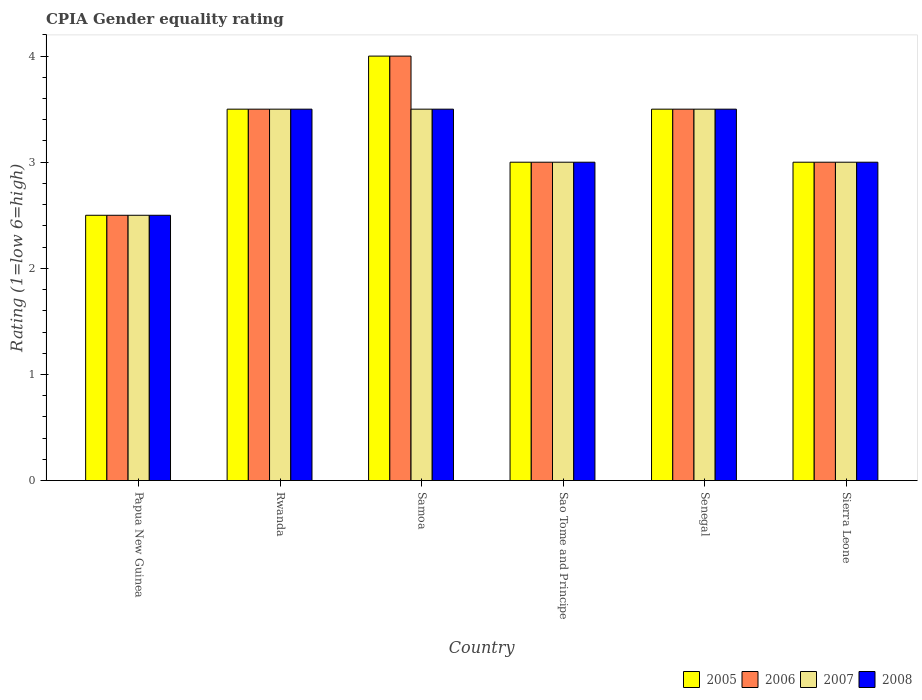How many different coloured bars are there?
Your response must be concise. 4. How many groups of bars are there?
Provide a short and direct response. 6. Are the number of bars per tick equal to the number of legend labels?
Offer a very short reply. Yes. Are the number of bars on each tick of the X-axis equal?
Offer a very short reply. Yes. How many bars are there on the 6th tick from the left?
Ensure brevity in your answer.  4. How many bars are there on the 1st tick from the right?
Your response must be concise. 4. What is the label of the 6th group of bars from the left?
Your response must be concise. Sierra Leone. In how many cases, is the number of bars for a given country not equal to the number of legend labels?
Your answer should be very brief. 0. In which country was the CPIA rating in 2007 maximum?
Ensure brevity in your answer.  Rwanda. In which country was the CPIA rating in 2006 minimum?
Keep it short and to the point. Papua New Guinea. What is the total CPIA rating in 2005 in the graph?
Offer a very short reply. 19.5. What is the difference between the CPIA rating in 2007 in Rwanda and that in Senegal?
Make the answer very short. 0. What is the difference between the CPIA rating in 2005 in Papua New Guinea and the CPIA rating in 2008 in Samoa?
Your answer should be very brief. -1. What is the average CPIA rating in 2005 per country?
Keep it short and to the point. 3.25. What is the ratio of the CPIA rating in 2008 in Senegal to that in Sierra Leone?
Your answer should be very brief. 1.17. What is the difference between the highest and the second highest CPIA rating in 2005?
Your answer should be very brief. -0.5. In how many countries, is the CPIA rating in 2007 greater than the average CPIA rating in 2007 taken over all countries?
Provide a short and direct response. 3. Is it the case that in every country, the sum of the CPIA rating in 2007 and CPIA rating in 2008 is greater than the sum of CPIA rating in 2006 and CPIA rating in 2005?
Make the answer very short. No. Is it the case that in every country, the sum of the CPIA rating in 2007 and CPIA rating in 2006 is greater than the CPIA rating in 2005?
Make the answer very short. Yes. How many bars are there?
Your response must be concise. 24. What is the difference between two consecutive major ticks on the Y-axis?
Offer a very short reply. 1. Are the values on the major ticks of Y-axis written in scientific E-notation?
Give a very brief answer. No. Does the graph contain any zero values?
Give a very brief answer. No. Does the graph contain grids?
Make the answer very short. No. Where does the legend appear in the graph?
Your answer should be very brief. Bottom right. What is the title of the graph?
Offer a terse response. CPIA Gender equality rating. What is the Rating (1=low 6=high) of 2006 in Papua New Guinea?
Offer a terse response. 2.5. What is the Rating (1=low 6=high) of 2008 in Papua New Guinea?
Offer a very short reply. 2.5. What is the Rating (1=low 6=high) of 2005 in Rwanda?
Make the answer very short. 3.5. What is the Rating (1=low 6=high) in 2007 in Rwanda?
Offer a terse response. 3.5. What is the Rating (1=low 6=high) in 2008 in Samoa?
Ensure brevity in your answer.  3.5. What is the Rating (1=low 6=high) of 2005 in Sao Tome and Principe?
Ensure brevity in your answer.  3. What is the Rating (1=low 6=high) of 2006 in Sao Tome and Principe?
Provide a short and direct response. 3. What is the Rating (1=low 6=high) of 2007 in Sao Tome and Principe?
Offer a terse response. 3. What is the Rating (1=low 6=high) in 2008 in Sao Tome and Principe?
Provide a short and direct response. 3. What is the Rating (1=low 6=high) of 2005 in Sierra Leone?
Provide a succinct answer. 3. What is the Rating (1=low 6=high) of 2006 in Sierra Leone?
Your answer should be very brief. 3. What is the Rating (1=low 6=high) in 2007 in Sierra Leone?
Your response must be concise. 3. What is the Rating (1=low 6=high) in 2008 in Sierra Leone?
Ensure brevity in your answer.  3. Across all countries, what is the maximum Rating (1=low 6=high) in 2006?
Provide a short and direct response. 4. Across all countries, what is the minimum Rating (1=low 6=high) of 2006?
Ensure brevity in your answer.  2.5. Across all countries, what is the minimum Rating (1=low 6=high) of 2008?
Make the answer very short. 2.5. What is the total Rating (1=low 6=high) of 2005 in the graph?
Give a very brief answer. 19.5. What is the total Rating (1=low 6=high) in 2006 in the graph?
Offer a very short reply. 19.5. What is the total Rating (1=low 6=high) in 2008 in the graph?
Keep it short and to the point. 19. What is the difference between the Rating (1=low 6=high) of 2006 in Papua New Guinea and that in Rwanda?
Give a very brief answer. -1. What is the difference between the Rating (1=low 6=high) of 2008 in Papua New Guinea and that in Rwanda?
Keep it short and to the point. -1. What is the difference between the Rating (1=low 6=high) in 2006 in Papua New Guinea and that in Samoa?
Provide a succinct answer. -1.5. What is the difference between the Rating (1=low 6=high) of 2007 in Papua New Guinea and that in Samoa?
Your answer should be very brief. -1. What is the difference between the Rating (1=low 6=high) of 2005 in Papua New Guinea and that in Senegal?
Make the answer very short. -1. What is the difference between the Rating (1=low 6=high) of 2006 in Papua New Guinea and that in Senegal?
Give a very brief answer. -1. What is the difference between the Rating (1=low 6=high) of 2007 in Papua New Guinea and that in Senegal?
Provide a succinct answer. -1. What is the difference between the Rating (1=low 6=high) of 2008 in Papua New Guinea and that in Senegal?
Ensure brevity in your answer.  -1. What is the difference between the Rating (1=low 6=high) of 2005 in Papua New Guinea and that in Sierra Leone?
Provide a succinct answer. -0.5. What is the difference between the Rating (1=low 6=high) of 2006 in Papua New Guinea and that in Sierra Leone?
Your answer should be compact. -0.5. What is the difference between the Rating (1=low 6=high) of 2008 in Papua New Guinea and that in Sierra Leone?
Offer a terse response. -0.5. What is the difference between the Rating (1=low 6=high) in 2006 in Rwanda and that in Samoa?
Provide a short and direct response. -0.5. What is the difference between the Rating (1=low 6=high) in 2007 in Rwanda and that in Samoa?
Offer a terse response. 0. What is the difference between the Rating (1=low 6=high) of 2005 in Rwanda and that in Sao Tome and Principe?
Offer a very short reply. 0.5. What is the difference between the Rating (1=low 6=high) in 2007 in Rwanda and that in Sao Tome and Principe?
Ensure brevity in your answer.  0.5. What is the difference between the Rating (1=low 6=high) in 2008 in Rwanda and that in Sao Tome and Principe?
Ensure brevity in your answer.  0.5. What is the difference between the Rating (1=low 6=high) in 2006 in Rwanda and that in Senegal?
Your response must be concise. 0. What is the difference between the Rating (1=low 6=high) in 2007 in Rwanda and that in Senegal?
Your answer should be very brief. 0. What is the difference between the Rating (1=low 6=high) of 2008 in Rwanda and that in Senegal?
Your response must be concise. 0. What is the difference between the Rating (1=low 6=high) in 2005 in Rwanda and that in Sierra Leone?
Your answer should be very brief. 0.5. What is the difference between the Rating (1=low 6=high) in 2007 in Rwanda and that in Sierra Leone?
Provide a short and direct response. 0.5. What is the difference between the Rating (1=low 6=high) of 2008 in Rwanda and that in Sierra Leone?
Your answer should be compact. 0.5. What is the difference between the Rating (1=low 6=high) in 2005 in Samoa and that in Sao Tome and Principe?
Offer a terse response. 1. What is the difference between the Rating (1=low 6=high) in 2007 in Samoa and that in Sao Tome and Principe?
Your answer should be compact. 0.5. What is the difference between the Rating (1=low 6=high) of 2008 in Samoa and that in Sao Tome and Principe?
Make the answer very short. 0.5. What is the difference between the Rating (1=low 6=high) of 2005 in Samoa and that in Senegal?
Your answer should be compact. 0.5. What is the difference between the Rating (1=low 6=high) in 2006 in Samoa and that in Sierra Leone?
Your answer should be very brief. 1. What is the difference between the Rating (1=low 6=high) in 2007 in Samoa and that in Sierra Leone?
Provide a succinct answer. 0.5. What is the difference between the Rating (1=low 6=high) of 2008 in Samoa and that in Sierra Leone?
Give a very brief answer. 0.5. What is the difference between the Rating (1=low 6=high) in 2006 in Sao Tome and Principe and that in Senegal?
Your answer should be very brief. -0.5. What is the difference between the Rating (1=low 6=high) of 2008 in Sao Tome and Principe and that in Senegal?
Provide a short and direct response. -0.5. What is the difference between the Rating (1=low 6=high) in 2005 in Sao Tome and Principe and that in Sierra Leone?
Make the answer very short. 0. What is the difference between the Rating (1=low 6=high) of 2007 in Sao Tome and Principe and that in Sierra Leone?
Offer a very short reply. 0. What is the difference between the Rating (1=low 6=high) of 2008 in Sao Tome and Principe and that in Sierra Leone?
Provide a succinct answer. 0. What is the difference between the Rating (1=low 6=high) in 2007 in Senegal and that in Sierra Leone?
Your response must be concise. 0.5. What is the difference between the Rating (1=low 6=high) in 2008 in Senegal and that in Sierra Leone?
Provide a short and direct response. 0.5. What is the difference between the Rating (1=low 6=high) of 2006 in Papua New Guinea and the Rating (1=low 6=high) of 2007 in Rwanda?
Offer a terse response. -1. What is the difference between the Rating (1=low 6=high) of 2007 in Papua New Guinea and the Rating (1=low 6=high) of 2008 in Rwanda?
Your answer should be compact. -1. What is the difference between the Rating (1=low 6=high) in 2005 in Papua New Guinea and the Rating (1=low 6=high) in 2008 in Samoa?
Keep it short and to the point. -1. What is the difference between the Rating (1=low 6=high) in 2006 in Papua New Guinea and the Rating (1=low 6=high) in 2007 in Samoa?
Your answer should be compact. -1. What is the difference between the Rating (1=low 6=high) in 2007 in Papua New Guinea and the Rating (1=low 6=high) in 2008 in Samoa?
Your answer should be compact. -1. What is the difference between the Rating (1=low 6=high) in 2006 in Papua New Guinea and the Rating (1=low 6=high) in 2007 in Sao Tome and Principe?
Ensure brevity in your answer.  -0.5. What is the difference between the Rating (1=low 6=high) in 2007 in Papua New Guinea and the Rating (1=low 6=high) in 2008 in Sao Tome and Principe?
Keep it short and to the point. -0.5. What is the difference between the Rating (1=low 6=high) in 2005 in Papua New Guinea and the Rating (1=low 6=high) in 2006 in Senegal?
Your response must be concise. -1. What is the difference between the Rating (1=low 6=high) in 2005 in Papua New Guinea and the Rating (1=low 6=high) in 2007 in Senegal?
Make the answer very short. -1. What is the difference between the Rating (1=low 6=high) of 2007 in Papua New Guinea and the Rating (1=low 6=high) of 2008 in Senegal?
Ensure brevity in your answer.  -1. What is the difference between the Rating (1=low 6=high) in 2005 in Papua New Guinea and the Rating (1=low 6=high) in 2006 in Sierra Leone?
Your response must be concise. -0.5. What is the difference between the Rating (1=low 6=high) of 2006 in Papua New Guinea and the Rating (1=low 6=high) of 2008 in Sierra Leone?
Offer a terse response. -0.5. What is the difference between the Rating (1=low 6=high) in 2007 in Papua New Guinea and the Rating (1=low 6=high) in 2008 in Sierra Leone?
Ensure brevity in your answer.  -0.5. What is the difference between the Rating (1=low 6=high) of 2005 in Rwanda and the Rating (1=low 6=high) of 2006 in Samoa?
Provide a short and direct response. -0.5. What is the difference between the Rating (1=low 6=high) in 2005 in Rwanda and the Rating (1=low 6=high) in 2007 in Samoa?
Offer a terse response. 0. What is the difference between the Rating (1=low 6=high) in 2005 in Rwanda and the Rating (1=low 6=high) in 2008 in Samoa?
Your answer should be very brief. 0. What is the difference between the Rating (1=low 6=high) in 2006 in Rwanda and the Rating (1=low 6=high) in 2007 in Samoa?
Offer a terse response. 0. What is the difference between the Rating (1=low 6=high) in 2006 in Rwanda and the Rating (1=low 6=high) in 2008 in Sao Tome and Principe?
Your response must be concise. 0.5. What is the difference between the Rating (1=low 6=high) of 2005 in Rwanda and the Rating (1=low 6=high) of 2008 in Senegal?
Keep it short and to the point. 0. What is the difference between the Rating (1=low 6=high) of 2005 in Rwanda and the Rating (1=low 6=high) of 2006 in Sierra Leone?
Offer a terse response. 0.5. What is the difference between the Rating (1=low 6=high) of 2005 in Rwanda and the Rating (1=low 6=high) of 2007 in Sierra Leone?
Keep it short and to the point. 0.5. What is the difference between the Rating (1=low 6=high) of 2005 in Rwanda and the Rating (1=low 6=high) of 2008 in Sierra Leone?
Provide a succinct answer. 0.5. What is the difference between the Rating (1=low 6=high) in 2006 in Rwanda and the Rating (1=low 6=high) in 2007 in Sierra Leone?
Offer a terse response. 0.5. What is the difference between the Rating (1=low 6=high) in 2006 in Rwanda and the Rating (1=low 6=high) in 2008 in Sierra Leone?
Ensure brevity in your answer.  0.5. What is the difference between the Rating (1=low 6=high) of 2007 in Rwanda and the Rating (1=low 6=high) of 2008 in Sierra Leone?
Offer a terse response. 0.5. What is the difference between the Rating (1=low 6=high) in 2005 in Samoa and the Rating (1=low 6=high) in 2006 in Sao Tome and Principe?
Offer a very short reply. 1. What is the difference between the Rating (1=low 6=high) in 2005 in Samoa and the Rating (1=low 6=high) in 2007 in Sao Tome and Principe?
Provide a succinct answer. 1. What is the difference between the Rating (1=low 6=high) of 2006 in Samoa and the Rating (1=low 6=high) of 2007 in Sao Tome and Principe?
Your response must be concise. 1. What is the difference between the Rating (1=low 6=high) of 2005 in Samoa and the Rating (1=low 6=high) of 2008 in Senegal?
Give a very brief answer. 0.5. What is the difference between the Rating (1=low 6=high) in 2006 in Samoa and the Rating (1=low 6=high) in 2007 in Senegal?
Your response must be concise. 0.5. What is the difference between the Rating (1=low 6=high) in 2007 in Samoa and the Rating (1=low 6=high) in 2008 in Senegal?
Give a very brief answer. 0. What is the difference between the Rating (1=low 6=high) of 2005 in Samoa and the Rating (1=low 6=high) of 2006 in Sierra Leone?
Provide a succinct answer. 1. What is the difference between the Rating (1=low 6=high) in 2005 in Samoa and the Rating (1=low 6=high) in 2007 in Sierra Leone?
Offer a terse response. 1. What is the difference between the Rating (1=low 6=high) of 2005 in Samoa and the Rating (1=low 6=high) of 2008 in Sierra Leone?
Provide a short and direct response. 1. What is the difference between the Rating (1=low 6=high) of 2006 in Samoa and the Rating (1=low 6=high) of 2007 in Sierra Leone?
Ensure brevity in your answer.  1. What is the difference between the Rating (1=low 6=high) in 2006 in Samoa and the Rating (1=low 6=high) in 2008 in Sierra Leone?
Your response must be concise. 1. What is the difference between the Rating (1=low 6=high) of 2007 in Samoa and the Rating (1=low 6=high) of 2008 in Sierra Leone?
Make the answer very short. 0.5. What is the difference between the Rating (1=low 6=high) in 2005 in Sao Tome and Principe and the Rating (1=low 6=high) in 2007 in Senegal?
Your response must be concise. -0.5. What is the difference between the Rating (1=low 6=high) in 2006 in Sao Tome and Principe and the Rating (1=low 6=high) in 2008 in Senegal?
Provide a short and direct response. -0.5. What is the difference between the Rating (1=low 6=high) in 2007 in Sao Tome and Principe and the Rating (1=low 6=high) in 2008 in Senegal?
Give a very brief answer. -0.5. What is the difference between the Rating (1=low 6=high) of 2006 in Sao Tome and Principe and the Rating (1=low 6=high) of 2007 in Sierra Leone?
Your answer should be compact. 0. What is the difference between the Rating (1=low 6=high) in 2006 in Sao Tome and Principe and the Rating (1=low 6=high) in 2008 in Sierra Leone?
Your answer should be compact. 0. What is the difference between the Rating (1=low 6=high) of 2007 in Sao Tome and Principe and the Rating (1=low 6=high) of 2008 in Sierra Leone?
Make the answer very short. 0. What is the difference between the Rating (1=low 6=high) of 2005 in Senegal and the Rating (1=low 6=high) of 2006 in Sierra Leone?
Offer a very short reply. 0.5. What is the difference between the Rating (1=low 6=high) in 2005 in Senegal and the Rating (1=low 6=high) in 2007 in Sierra Leone?
Your answer should be very brief. 0.5. What is the average Rating (1=low 6=high) of 2007 per country?
Your response must be concise. 3.17. What is the average Rating (1=low 6=high) of 2008 per country?
Make the answer very short. 3.17. What is the difference between the Rating (1=low 6=high) of 2005 and Rating (1=low 6=high) of 2006 in Papua New Guinea?
Your answer should be compact. 0. What is the difference between the Rating (1=low 6=high) in 2006 and Rating (1=low 6=high) in 2008 in Papua New Guinea?
Keep it short and to the point. 0. What is the difference between the Rating (1=low 6=high) in 2005 and Rating (1=low 6=high) in 2007 in Rwanda?
Provide a short and direct response. 0. What is the difference between the Rating (1=low 6=high) in 2005 and Rating (1=low 6=high) in 2008 in Rwanda?
Keep it short and to the point. 0. What is the difference between the Rating (1=low 6=high) of 2006 and Rating (1=low 6=high) of 2007 in Rwanda?
Offer a very short reply. 0. What is the difference between the Rating (1=low 6=high) in 2006 and Rating (1=low 6=high) in 2008 in Rwanda?
Give a very brief answer. 0. What is the difference between the Rating (1=low 6=high) of 2007 and Rating (1=low 6=high) of 2008 in Rwanda?
Offer a very short reply. 0. What is the difference between the Rating (1=low 6=high) of 2005 and Rating (1=low 6=high) of 2007 in Samoa?
Ensure brevity in your answer.  0.5. What is the difference between the Rating (1=low 6=high) in 2006 and Rating (1=low 6=high) in 2007 in Samoa?
Your answer should be very brief. 0.5. What is the difference between the Rating (1=low 6=high) of 2006 and Rating (1=low 6=high) of 2008 in Samoa?
Make the answer very short. 0.5. What is the difference between the Rating (1=low 6=high) in 2005 and Rating (1=low 6=high) in 2006 in Sao Tome and Principe?
Give a very brief answer. 0. What is the difference between the Rating (1=low 6=high) of 2005 and Rating (1=low 6=high) of 2007 in Senegal?
Provide a succinct answer. 0. What is the difference between the Rating (1=low 6=high) in 2005 and Rating (1=low 6=high) in 2008 in Senegal?
Give a very brief answer. 0. What is the difference between the Rating (1=low 6=high) of 2006 and Rating (1=low 6=high) of 2007 in Senegal?
Offer a terse response. 0. What is the difference between the Rating (1=low 6=high) of 2006 and Rating (1=low 6=high) of 2008 in Senegal?
Ensure brevity in your answer.  0. What is the difference between the Rating (1=low 6=high) in 2005 and Rating (1=low 6=high) in 2006 in Sierra Leone?
Your response must be concise. 0. What is the difference between the Rating (1=low 6=high) of 2005 and Rating (1=low 6=high) of 2007 in Sierra Leone?
Your answer should be compact. 0. What is the difference between the Rating (1=low 6=high) in 2006 and Rating (1=low 6=high) in 2007 in Sierra Leone?
Make the answer very short. 0. What is the ratio of the Rating (1=low 6=high) of 2005 in Papua New Guinea to that in Rwanda?
Keep it short and to the point. 0.71. What is the ratio of the Rating (1=low 6=high) of 2007 in Papua New Guinea to that in Rwanda?
Your response must be concise. 0.71. What is the ratio of the Rating (1=low 6=high) in 2008 in Papua New Guinea to that in Rwanda?
Give a very brief answer. 0.71. What is the ratio of the Rating (1=low 6=high) of 2005 in Papua New Guinea to that in Samoa?
Provide a succinct answer. 0.62. What is the ratio of the Rating (1=low 6=high) in 2006 in Papua New Guinea to that in Samoa?
Offer a very short reply. 0.62. What is the ratio of the Rating (1=low 6=high) in 2007 in Papua New Guinea to that in Samoa?
Provide a succinct answer. 0.71. What is the ratio of the Rating (1=low 6=high) of 2008 in Papua New Guinea to that in Samoa?
Offer a very short reply. 0.71. What is the ratio of the Rating (1=low 6=high) of 2005 in Papua New Guinea to that in Sao Tome and Principe?
Give a very brief answer. 0.83. What is the ratio of the Rating (1=low 6=high) of 2007 in Papua New Guinea to that in Sao Tome and Principe?
Make the answer very short. 0.83. What is the ratio of the Rating (1=low 6=high) in 2005 in Papua New Guinea to that in Senegal?
Provide a succinct answer. 0.71. What is the ratio of the Rating (1=low 6=high) in 2007 in Papua New Guinea to that in Senegal?
Ensure brevity in your answer.  0.71. What is the ratio of the Rating (1=low 6=high) of 2006 in Papua New Guinea to that in Sierra Leone?
Keep it short and to the point. 0.83. What is the ratio of the Rating (1=low 6=high) in 2005 in Rwanda to that in Samoa?
Provide a short and direct response. 0.88. What is the ratio of the Rating (1=low 6=high) in 2005 in Rwanda to that in Sao Tome and Principe?
Offer a terse response. 1.17. What is the ratio of the Rating (1=low 6=high) of 2006 in Rwanda to that in Sao Tome and Principe?
Offer a very short reply. 1.17. What is the ratio of the Rating (1=low 6=high) in 2007 in Rwanda to that in Sao Tome and Principe?
Your answer should be compact. 1.17. What is the ratio of the Rating (1=low 6=high) of 2008 in Rwanda to that in Sao Tome and Principe?
Provide a short and direct response. 1.17. What is the ratio of the Rating (1=low 6=high) in 2005 in Rwanda to that in Senegal?
Ensure brevity in your answer.  1. What is the ratio of the Rating (1=low 6=high) in 2005 in Rwanda to that in Sierra Leone?
Provide a short and direct response. 1.17. What is the ratio of the Rating (1=low 6=high) in 2007 in Rwanda to that in Sierra Leone?
Your answer should be very brief. 1.17. What is the ratio of the Rating (1=low 6=high) of 2008 in Rwanda to that in Sierra Leone?
Offer a terse response. 1.17. What is the ratio of the Rating (1=low 6=high) in 2006 in Samoa to that in Sao Tome and Principe?
Make the answer very short. 1.33. What is the ratio of the Rating (1=low 6=high) in 2008 in Samoa to that in Sao Tome and Principe?
Make the answer very short. 1.17. What is the ratio of the Rating (1=low 6=high) of 2007 in Samoa to that in Senegal?
Keep it short and to the point. 1. What is the ratio of the Rating (1=low 6=high) of 2008 in Samoa to that in Senegal?
Provide a succinct answer. 1. What is the ratio of the Rating (1=low 6=high) in 2005 in Samoa to that in Sierra Leone?
Your response must be concise. 1.33. What is the ratio of the Rating (1=low 6=high) of 2006 in Samoa to that in Sierra Leone?
Your response must be concise. 1.33. What is the ratio of the Rating (1=low 6=high) in 2006 in Sao Tome and Principe to that in Senegal?
Give a very brief answer. 0.86. What is the ratio of the Rating (1=low 6=high) of 2007 in Sao Tome and Principe to that in Senegal?
Your answer should be compact. 0.86. What is the ratio of the Rating (1=low 6=high) of 2008 in Sao Tome and Principe to that in Senegal?
Keep it short and to the point. 0.86. What is the ratio of the Rating (1=low 6=high) in 2006 in Sao Tome and Principe to that in Sierra Leone?
Provide a short and direct response. 1. What is the ratio of the Rating (1=low 6=high) of 2007 in Sao Tome and Principe to that in Sierra Leone?
Your response must be concise. 1. What is the ratio of the Rating (1=low 6=high) in 2006 in Senegal to that in Sierra Leone?
Keep it short and to the point. 1.17. What is the ratio of the Rating (1=low 6=high) in 2008 in Senegal to that in Sierra Leone?
Provide a succinct answer. 1.17. What is the difference between the highest and the second highest Rating (1=low 6=high) in 2005?
Give a very brief answer. 0.5. What is the difference between the highest and the second highest Rating (1=low 6=high) of 2006?
Provide a short and direct response. 0.5. What is the difference between the highest and the second highest Rating (1=low 6=high) in 2007?
Your response must be concise. 0. What is the difference between the highest and the second highest Rating (1=low 6=high) in 2008?
Offer a terse response. 0. 